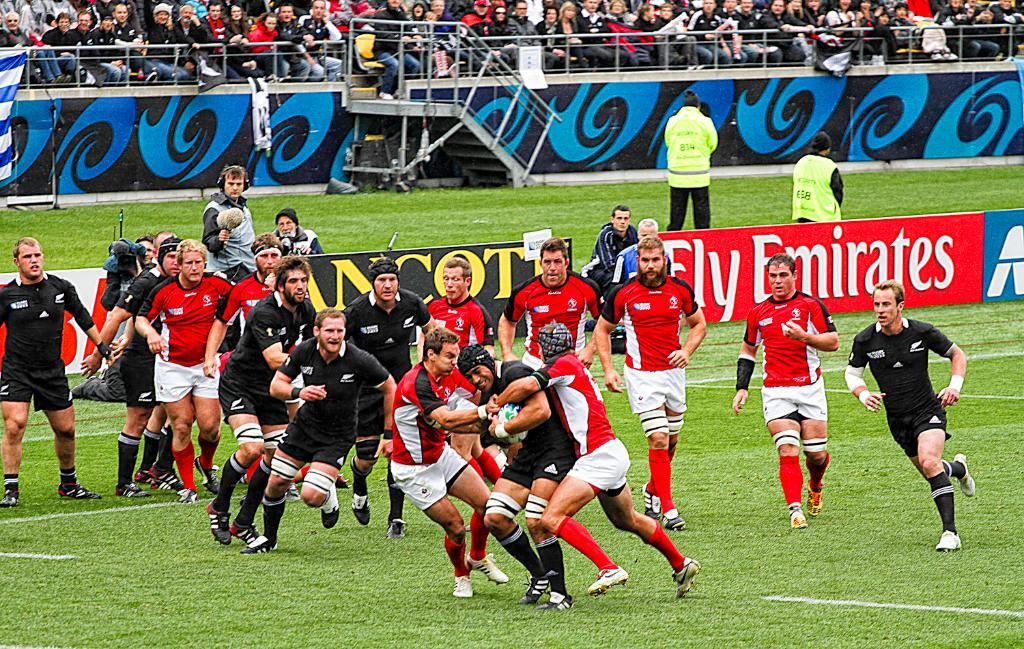<image>
Share a concise interpretation of the image provided. players going at it with a fly emirates ad in the back 